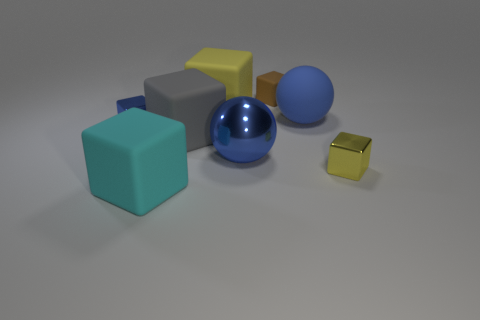There is a blue object that is the same size as the yellow shiny thing; what is it made of?
Offer a terse response. Metal. Is the number of tiny objects left of the big blue matte object less than the number of small green blocks?
Your answer should be very brief. No. What is the shape of the rubber thing in front of the small object that is in front of the cube to the left of the cyan object?
Your response must be concise. Cube. There is a blue metal thing right of the cyan block; what is its size?
Keep it short and to the point. Large. There is a blue metallic object that is the same size as the brown matte thing; what shape is it?
Offer a very short reply. Cube. What number of objects are brown cylinders or blue spheres behind the gray rubber block?
Provide a succinct answer. 1. There is a shiny thing that is left of the yellow object that is left of the tiny yellow block; how many big gray rubber things are left of it?
Make the answer very short. 0. There is a big sphere that is the same material as the big cyan block; what is its color?
Offer a terse response. Blue. There is a rubber object that is on the left side of the gray cube; is it the same size as the gray block?
Provide a short and direct response. Yes. How many things are either cyan rubber cubes or large blue matte balls?
Ensure brevity in your answer.  2. 